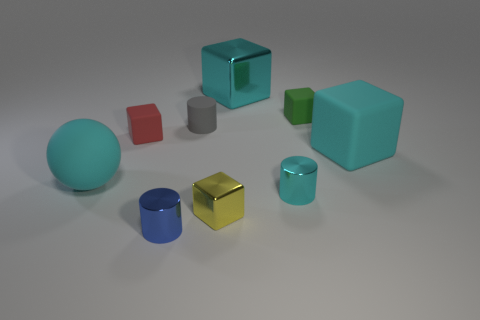Subtract all tiny shiny cylinders. How many cylinders are left? 1 Subtract all red cubes. How many cubes are left? 4 Add 1 blue cylinders. How many objects exist? 10 Add 8 green things. How many green things exist? 9 Subtract 0 blue blocks. How many objects are left? 9 Subtract all blocks. How many objects are left? 4 Subtract 2 cylinders. How many cylinders are left? 1 Subtract all blue cylinders. Subtract all purple spheres. How many cylinders are left? 2 Subtract all blue cylinders. How many brown spheres are left? 0 Subtract all small yellow metal things. Subtract all large rubber spheres. How many objects are left? 7 